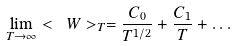Convert formula to latex. <formula><loc_0><loc_0><loc_500><loc_500>\lim _ { T \rightarrow \infty } < \ W > _ { T } = \frac { C _ { 0 } } { T ^ { 1 / 2 } } + \frac { C _ { 1 } } { T } + \dots</formula> 